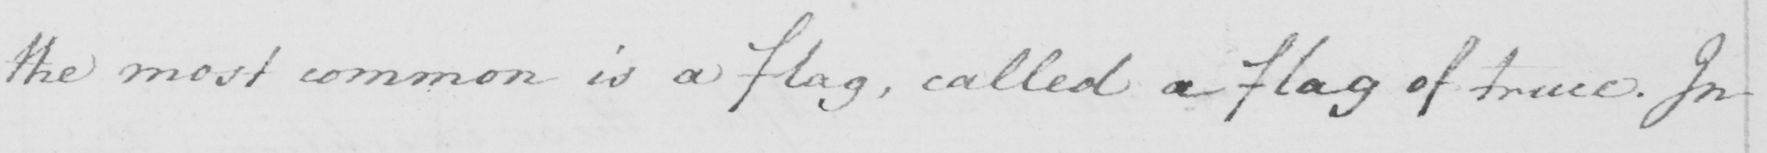Please provide the text content of this handwritten line. the most common is a flag , called a flag of truce . In 